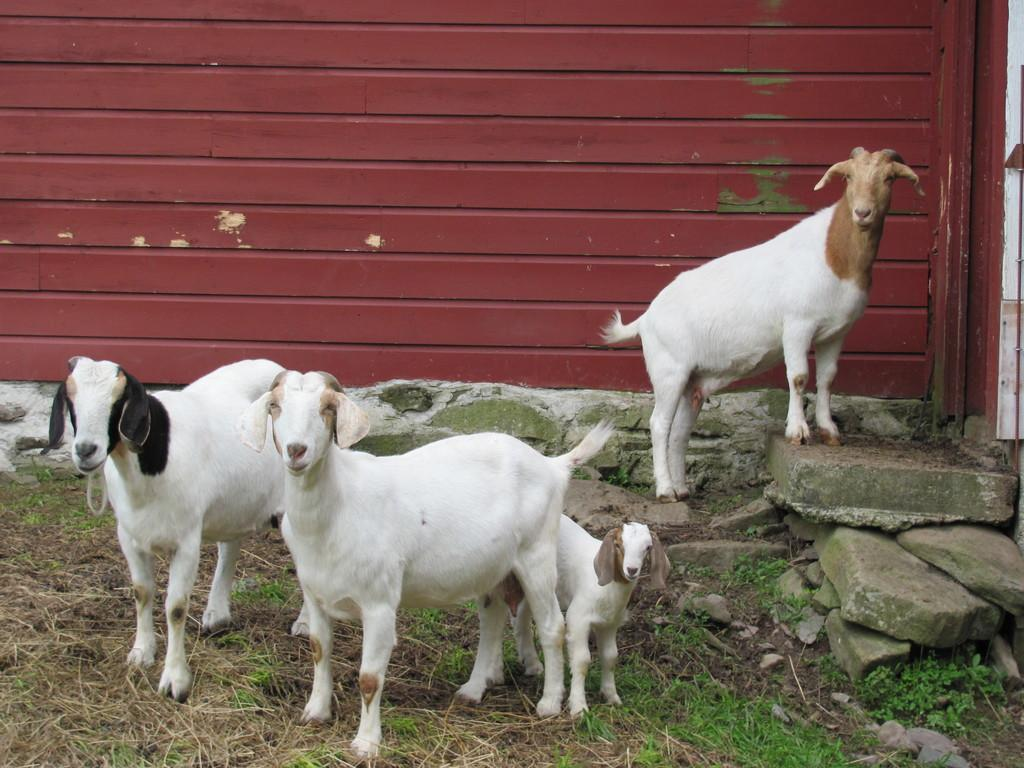What animals are present in the image? There are goats in the image. What type of vegetation can be seen in the image? There is grass in the image. What other objects can be seen in the image? There are stones in the image. What is visible in the background of the image? There is a wall in the background of the image. What type of curtain can be seen hanging from the goat's neck in the image? There is no curtain present in the image, nor is there any indication that the goats have anything hanging from their necks. 